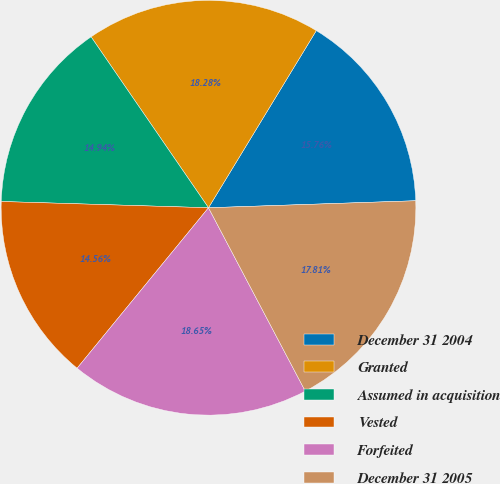Convert chart. <chart><loc_0><loc_0><loc_500><loc_500><pie_chart><fcel>December 31 2004<fcel>Granted<fcel>Assumed in acquisition<fcel>Vested<fcel>Forfeited<fcel>December 31 2005<nl><fcel>15.76%<fcel>18.28%<fcel>14.94%<fcel>14.56%<fcel>18.65%<fcel>17.81%<nl></chart> 